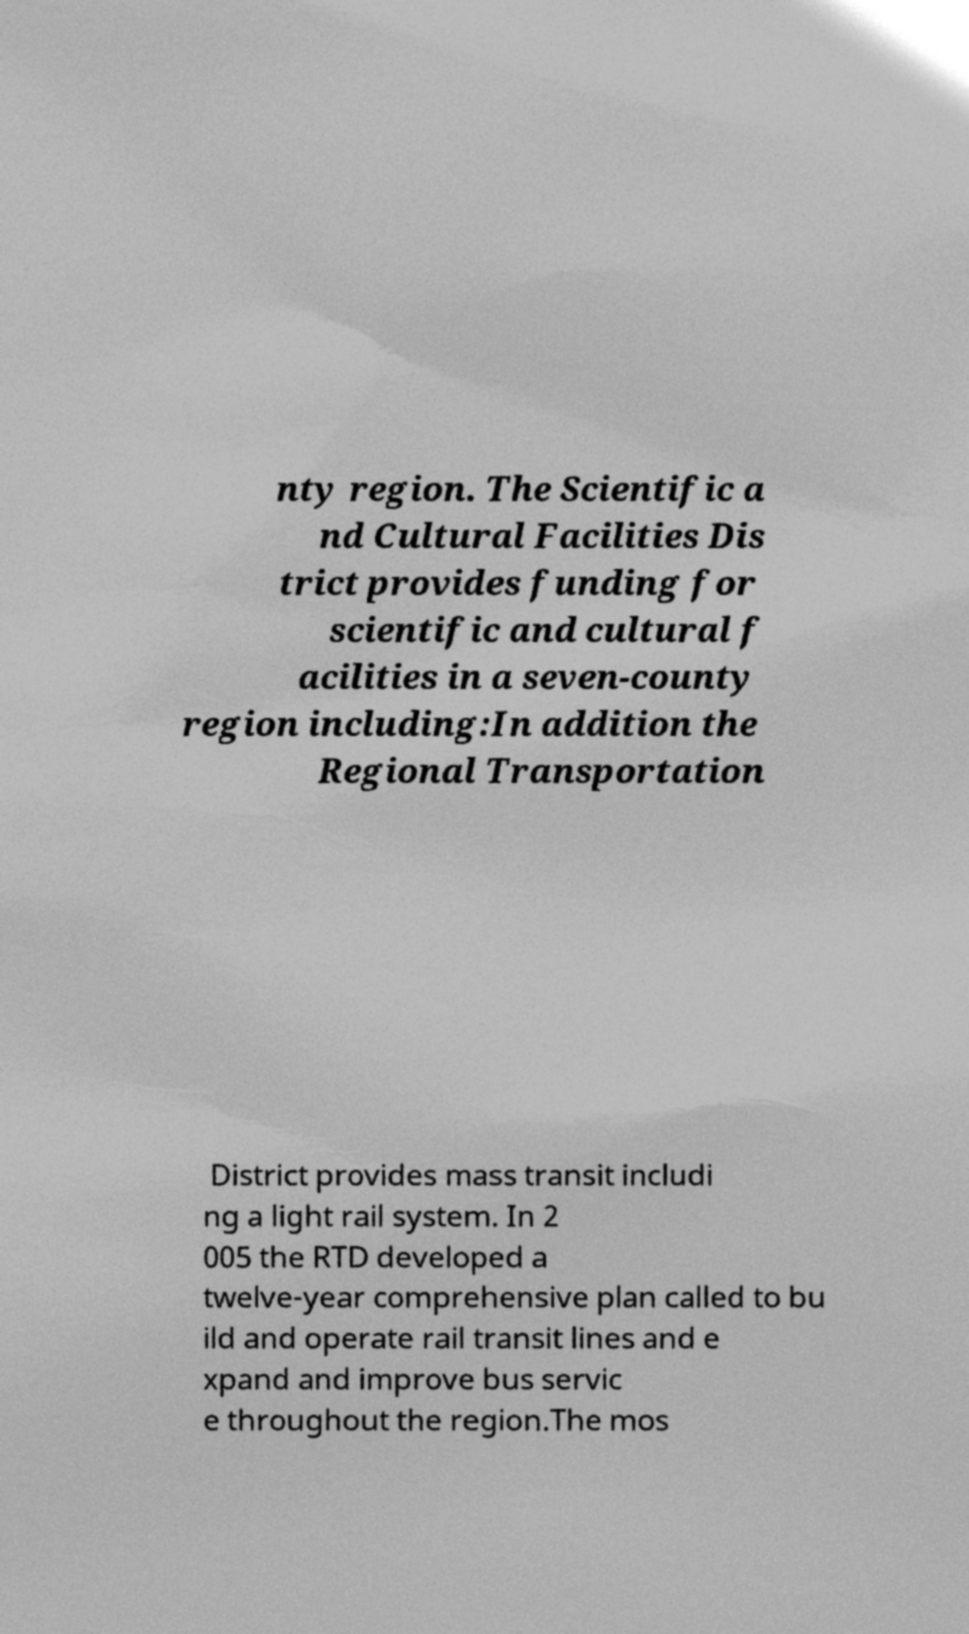What messages or text are displayed in this image? I need them in a readable, typed format. nty region. The Scientific a nd Cultural Facilities Dis trict provides funding for scientific and cultural f acilities in a seven-county region including:In addition the Regional Transportation District provides mass transit includi ng a light rail system. In 2 005 the RTD developed a twelve-year comprehensive plan called to bu ild and operate rail transit lines and e xpand and improve bus servic e throughout the region.The mos 